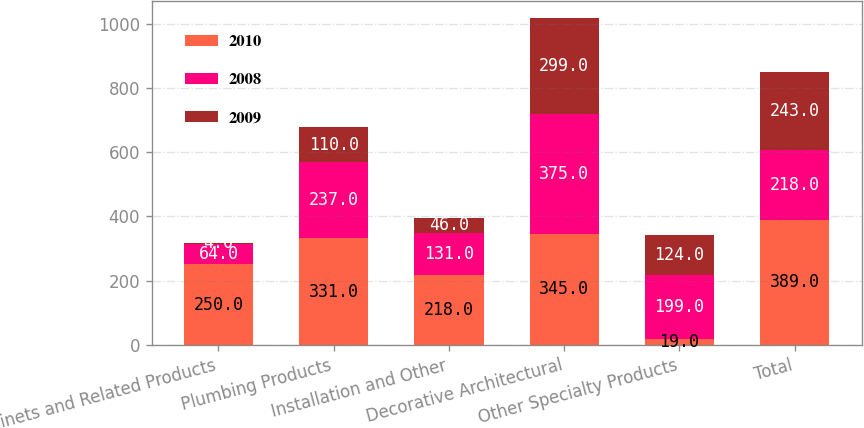Convert chart. <chart><loc_0><loc_0><loc_500><loc_500><stacked_bar_chart><ecel><fcel>Cabinets and Related Products<fcel>Plumbing Products<fcel>Installation and Other<fcel>Decorative Architectural<fcel>Other Specialty Products<fcel>Total<nl><fcel>2010<fcel>250<fcel>331<fcel>218<fcel>345<fcel>19<fcel>389<nl><fcel>2008<fcel>64<fcel>237<fcel>131<fcel>375<fcel>199<fcel>218<nl><fcel>2009<fcel>4<fcel>110<fcel>46<fcel>299<fcel>124<fcel>243<nl></chart> 